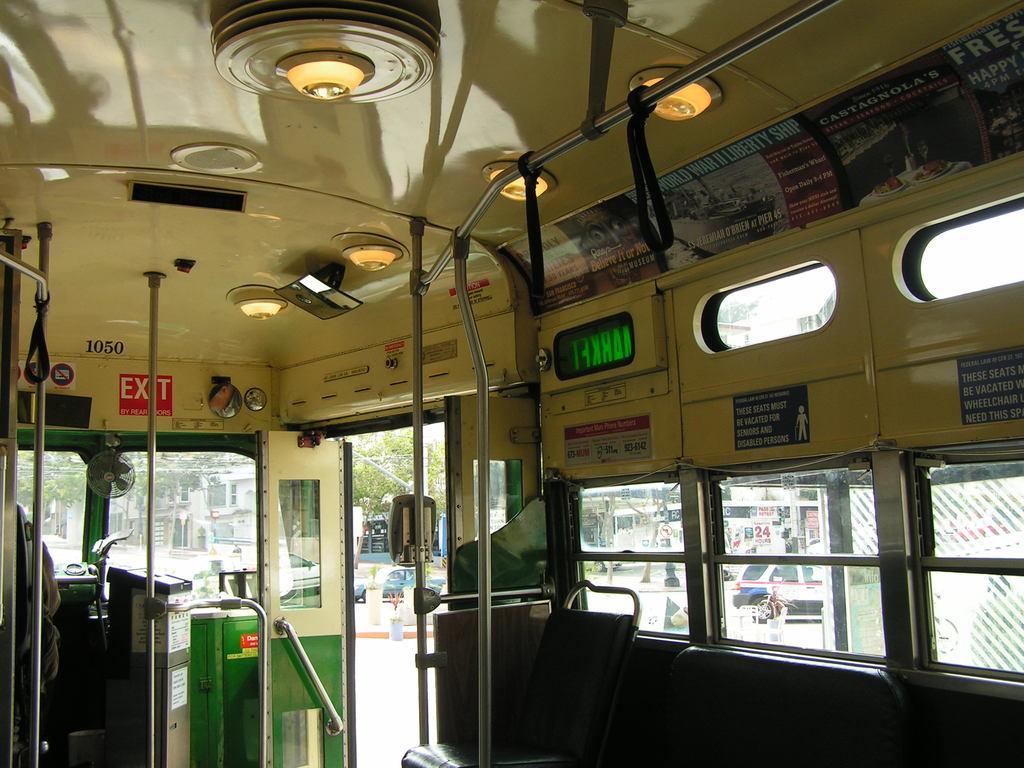How would you summarize this image in a sentence or two? This picture is an inside view of a vehicle. In this picture we can see the rods, seats, windows, boards, lights, posters, roof. Through windows we can see the vehicles, buildings, road, trees and some people. 